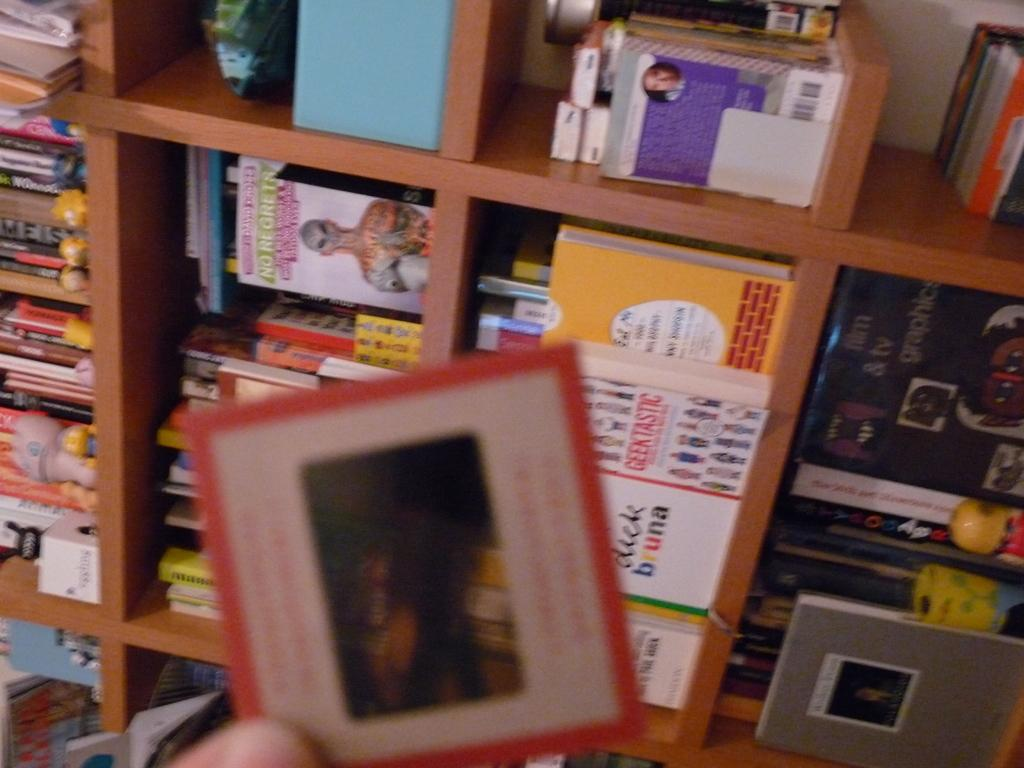<image>
Relay a brief, clear account of the picture shown. A person is holding up a card in front of a book shelf with a book by Dick Bruna. 